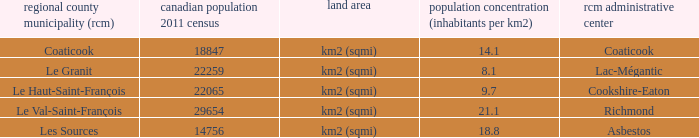What is the land area for the RCM that has a population of 18847? Km2 (sqmi). 